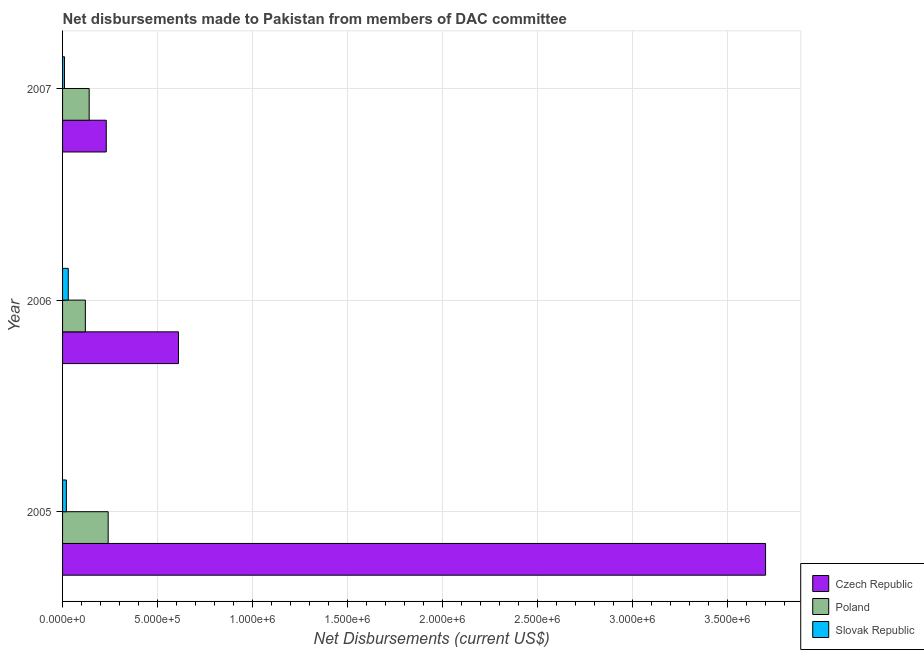Are the number of bars per tick equal to the number of legend labels?
Your answer should be very brief. Yes. Are the number of bars on each tick of the Y-axis equal?
Give a very brief answer. Yes. How many bars are there on the 1st tick from the top?
Offer a terse response. 3. What is the label of the 2nd group of bars from the top?
Your answer should be compact. 2006. What is the net disbursements made by czech republic in 2005?
Provide a succinct answer. 3.70e+06. Across all years, what is the maximum net disbursements made by czech republic?
Ensure brevity in your answer.  3.70e+06. Across all years, what is the minimum net disbursements made by slovak republic?
Give a very brief answer. 10000. What is the total net disbursements made by slovak republic in the graph?
Make the answer very short. 6.00e+04. What is the difference between the net disbursements made by slovak republic in 2005 and that in 2006?
Offer a very short reply. -10000. What is the difference between the net disbursements made by slovak republic in 2006 and the net disbursements made by poland in 2005?
Make the answer very short. -2.10e+05. In the year 2007, what is the difference between the net disbursements made by slovak republic and net disbursements made by poland?
Offer a terse response. -1.30e+05. In how many years, is the net disbursements made by slovak republic greater than 3200000 US$?
Provide a succinct answer. 0. What is the ratio of the net disbursements made by slovak republic in 2005 to that in 2006?
Your answer should be very brief. 0.67. Is the net disbursements made by poland in 2005 less than that in 2006?
Make the answer very short. No. Is the difference between the net disbursements made by poland in 2006 and 2007 greater than the difference between the net disbursements made by slovak republic in 2006 and 2007?
Offer a very short reply. No. What is the difference between the highest and the lowest net disbursements made by slovak republic?
Your answer should be very brief. 2.00e+04. In how many years, is the net disbursements made by czech republic greater than the average net disbursements made by czech republic taken over all years?
Provide a succinct answer. 1. What does the 3rd bar from the top in 2007 represents?
Provide a succinct answer. Czech Republic. Is it the case that in every year, the sum of the net disbursements made by czech republic and net disbursements made by poland is greater than the net disbursements made by slovak republic?
Make the answer very short. Yes. How many bars are there?
Provide a short and direct response. 9. Are all the bars in the graph horizontal?
Provide a short and direct response. Yes. What is the difference between two consecutive major ticks on the X-axis?
Keep it short and to the point. 5.00e+05. Does the graph contain any zero values?
Offer a very short reply. No. How many legend labels are there?
Keep it short and to the point. 3. What is the title of the graph?
Make the answer very short. Net disbursements made to Pakistan from members of DAC committee. What is the label or title of the X-axis?
Make the answer very short. Net Disbursements (current US$). What is the Net Disbursements (current US$) in Czech Republic in 2005?
Give a very brief answer. 3.70e+06. What is the Net Disbursements (current US$) of Poland in 2005?
Provide a succinct answer. 2.40e+05. What is the Net Disbursements (current US$) of Czech Republic in 2006?
Provide a short and direct response. 6.10e+05. What is the Net Disbursements (current US$) of Slovak Republic in 2006?
Make the answer very short. 3.00e+04. Across all years, what is the maximum Net Disbursements (current US$) in Czech Republic?
Your answer should be very brief. 3.70e+06. Across all years, what is the maximum Net Disbursements (current US$) of Poland?
Your answer should be compact. 2.40e+05. What is the total Net Disbursements (current US$) of Czech Republic in the graph?
Offer a very short reply. 4.54e+06. What is the total Net Disbursements (current US$) of Poland in the graph?
Keep it short and to the point. 5.00e+05. What is the total Net Disbursements (current US$) in Slovak Republic in the graph?
Your answer should be compact. 6.00e+04. What is the difference between the Net Disbursements (current US$) of Czech Republic in 2005 and that in 2006?
Provide a short and direct response. 3.09e+06. What is the difference between the Net Disbursements (current US$) of Czech Republic in 2005 and that in 2007?
Your answer should be very brief. 3.47e+06. What is the difference between the Net Disbursements (current US$) of Slovak Republic in 2005 and that in 2007?
Offer a very short reply. 10000. What is the difference between the Net Disbursements (current US$) of Czech Republic in 2005 and the Net Disbursements (current US$) of Poland in 2006?
Keep it short and to the point. 3.58e+06. What is the difference between the Net Disbursements (current US$) in Czech Republic in 2005 and the Net Disbursements (current US$) in Slovak Republic in 2006?
Ensure brevity in your answer.  3.67e+06. What is the difference between the Net Disbursements (current US$) of Poland in 2005 and the Net Disbursements (current US$) of Slovak Republic in 2006?
Offer a terse response. 2.10e+05. What is the difference between the Net Disbursements (current US$) in Czech Republic in 2005 and the Net Disbursements (current US$) in Poland in 2007?
Your response must be concise. 3.56e+06. What is the difference between the Net Disbursements (current US$) of Czech Republic in 2005 and the Net Disbursements (current US$) of Slovak Republic in 2007?
Provide a succinct answer. 3.69e+06. What is the difference between the Net Disbursements (current US$) in Czech Republic in 2006 and the Net Disbursements (current US$) in Poland in 2007?
Your response must be concise. 4.70e+05. What is the average Net Disbursements (current US$) of Czech Republic per year?
Make the answer very short. 1.51e+06. What is the average Net Disbursements (current US$) in Poland per year?
Your answer should be very brief. 1.67e+05. In the year 2005, what is the difference between the Net Disbursements (current US$) in Czech Republic and Net Disbursements (current US$) in Poland?
Your answer should be compact. 3.46e+06. In the year 2005, what is the difference between the Net Disbursements (current US$) of Czech Republic and Net Disbursements (current US$) of Slovak Republic?
Provide a short and direct response. 3.68e+06. In the year 2006, what is the difference between the Net Disbursements (current US$) in Czech Republic and Net Disbursements (current US$) in Slovak Republic?
Your answer should be very brief. 5.80e+05. What is the ratio of the Net Disbursements (current US$) in Czech Republic in 2005 to that in 2006?
Provide a short and direct response. 6.07. What is the ratio of the Net Disbursements (current US$) of Slovak Republic in 2005 to that in 2006?
Your response must be concise. 0.67. What is the ratio of the Net Disbursements (current US$) of Czech Republic in 2005 to that in 2007?
Your answer should be very brief. 16.09. What is the ratio of the Net Disbursements (current US$) of Poland in 2005 to that in 2007?
Give a very brief answer. 1.71. What is the ratio of the Net Disbursements (current US$) of Czech Republic in 2006 to that in 2007?
Keep it short and to the point. 2.65. What is the ratio of the Net Disbursements (current US$) in Slovak Republic in 2006 to that in 2007?
Provide a short and direct response. 3. What is the difference between the highest and the second highest Net Disbursements (current US$) of Czech Republic?
Your response must be concise. 3.09e+06. What is the difference between the highest and the lowest Net Disbursements (current US$) of Czech Republic?
Your answer should be very brief. 3.47e+06. What is the difference between the highest and the lowest Net Disbursements (current US$) of Poland?
Keep it short and to the point. 1.20e+05. What is the difference between the highest and the lowest Net Disbursements (current US$) in Slovak Republic?
Your response must be concise. 2.00e+04. 